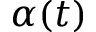<formula> <loc_0><loc_0><loc_500><loc_500>\alpha ( t )</formula> 